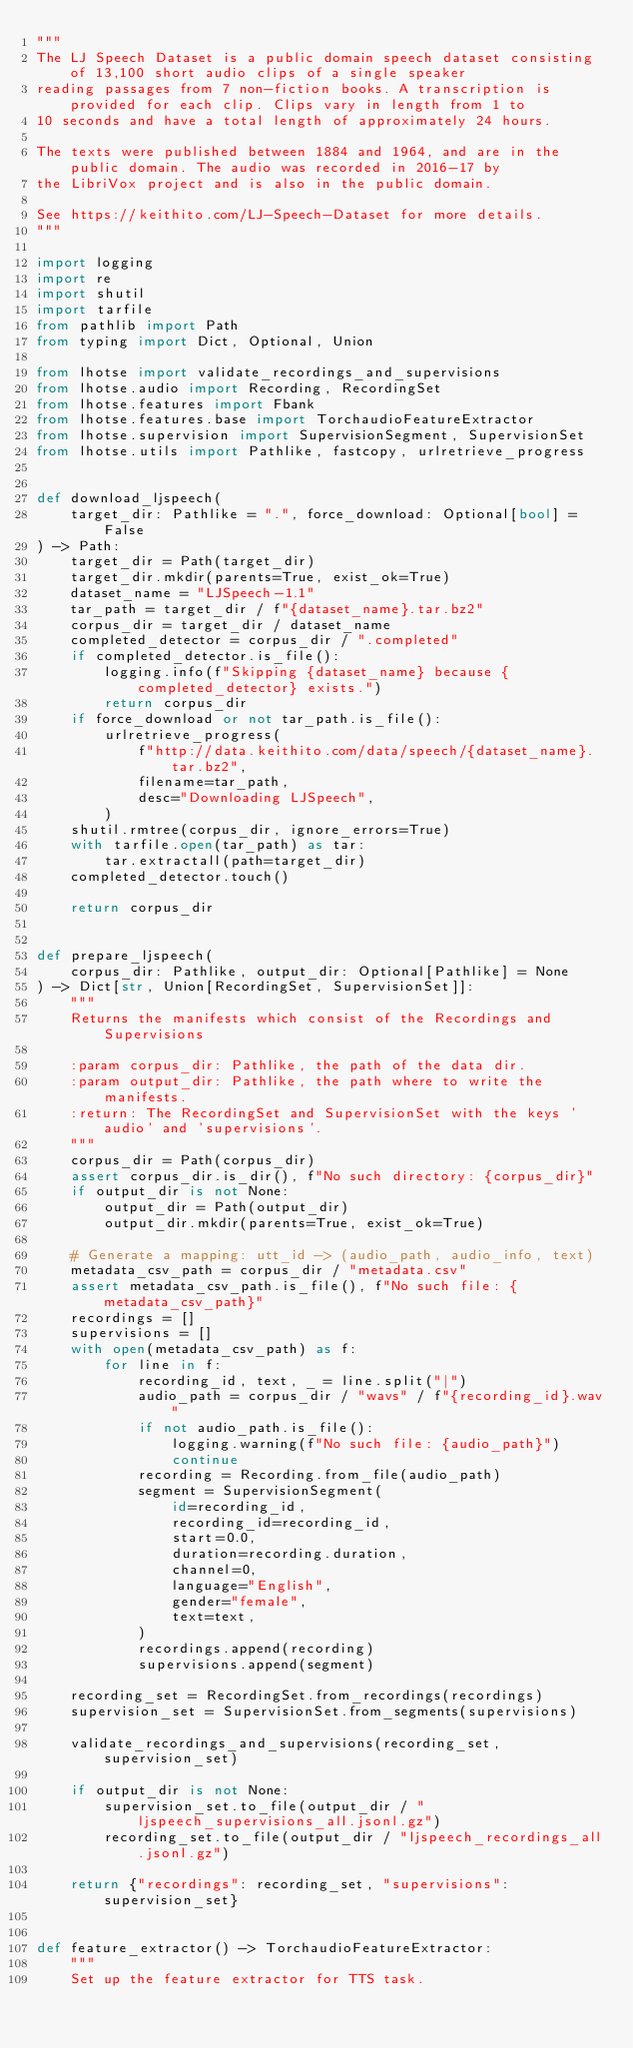<code> <loc_0><loc_0><loc_500><loc_500><_Python_>"""
The LJ Speech Dataset is a public domain speech dataset consisting of 13,100 short audio clips of a single speaker
reading passages from 7 non-fiction books. A transcription is provided for each clip. Clips vary in length from 1 to
10 seconds and have a total length of approximately 24 hours.

The texts were published between 1884 and 1964, and are in the public domain. The audio was recorded in 2016-17 by
the LibriVox project and is also in the public domain.

See https://keithito.com/LJ-Speech-Dataset for more details.
"""

import logging
import re
import shutil
import tarfile
from pathlib import Path
from typing import Dict, Optional, Union

from lhotse import validate_recordings_and_supervisions
from lhotse.audio import Recording, RecordingSet
from lhotse.features import Fbank
from lhotse.features.base import TorchaudioFeatureExtractor
from lhotse.supervision import SupervisionSegment, SupervisionSet
from lhotse.utils import Pathlike, fastcopy, urlretrieve_progress


def download_ljspeech(
    target_dir: Pathlike = ".", force_download: Optional[bool] = False
) -> Path:
    target_dir = Path(target_dir)
    target_dir.mkdir(parents=True, exist_ok=True)
    dataset_name = "LJSpeech-1.1"
    tar_path = target_dir / f"{dataset_name}.tar.bz2"
    corpus_dir = target_dir / dataset_name
    completed_detector = corpus_dir / ".completed"
    if completed_detector.is_file():
        logging.info(f"Skipping {dataset_name} because {completed_detector} exists.")
        return corpus_dir
    if force_download or not tar_path.is_file():
        urlretrieve_progress(
            f"http://data.keithito.com/data/speech/{dataset_name}.tar.bz2",
            filename=tar_path,
            desc="Downloading LJSpeech",
        )
    shutil.rmtree(corpus_dir, ignore_errors=True)
    with tarfile.open(tar_path) as tar:
        tar.extractall(path=target_dir)
    completed_detector.touch()

    return corpus_dir


def prepare_ljspeech(
    corpus_dir: Pathlike, output_dir: Optional[Pathlike] = None
) -> Dict[str, Union[RecordingSet, SupervisionSet]]:
    """
    Returns the manifests which consist of the Recordings and Supervisions

    :param corpus_dir: Pathlike, the path of the data dir.
    :param output_dir: Pathlike, the path where to write the manifests.
    :return: The RecordingSet and SupervisionSet with the keys 'audio' and 'supervisions'.
    """
    corpus_dir = Path(corpus_dir)
    assert corpus_dir.is_dir(), f"No such directory: {corpus_dir}"
    if output_dir is not None:
        output_dir = Path(output_dir)
        output_dir.mkdir(parents=True, exist_ok=True)

    # Generate a mapping: utt_id -> (audio_path, audio_info, text)
    metadata_csv_path = corpus_dir / "metadata.csv"
    assert metadata_csv_path.is_file(), f"No such file: {metadata_csv_path}"
    recordings = []
    supervisions = []
    with open(metadata_csv_path) as f:
        for line in f:
            recording_id, text, _ = line.split("|")
            audio_path = corpus_dir / "wavs" / f"{recording_id}.wav"
            if not audio_path.is_file():
                logging.warning(f"No such file: {audio_path}")
                continue
            recording = Recording.from_file(audio_path)
            segment = SupervisionSegment(
                id=recording_id,
                recording_id=recording_id,
                start=0.0,
                duration=recording.duration,
                channel=0,
                language="English",
                gender="female",
                text=text,
            )
            recordings.append(recording)
            supervisions.append(segment)

    recording_set = RecordingSet.from_recordings(recordings)
    supervision_set = SupervisionSet.from_segments(supervisions)

    validate_recordings_and_supervisions(recording_set, supervision_set)

    if output_dir is not None:
        supervision_set.to_file(output_dir / "ljspeech_supervisions_all.jsonl.gz")
        recording_set.to_file(output_dir / "ljspeech_recordings_all.jsonl.gz")

    return {"recordings": recording_set, "supervisions": supervision_set}


def feature_extractor() -> TorchaudioFeatureExtractor:
    """
    Set up the feature extractor for TTS task.</code> 